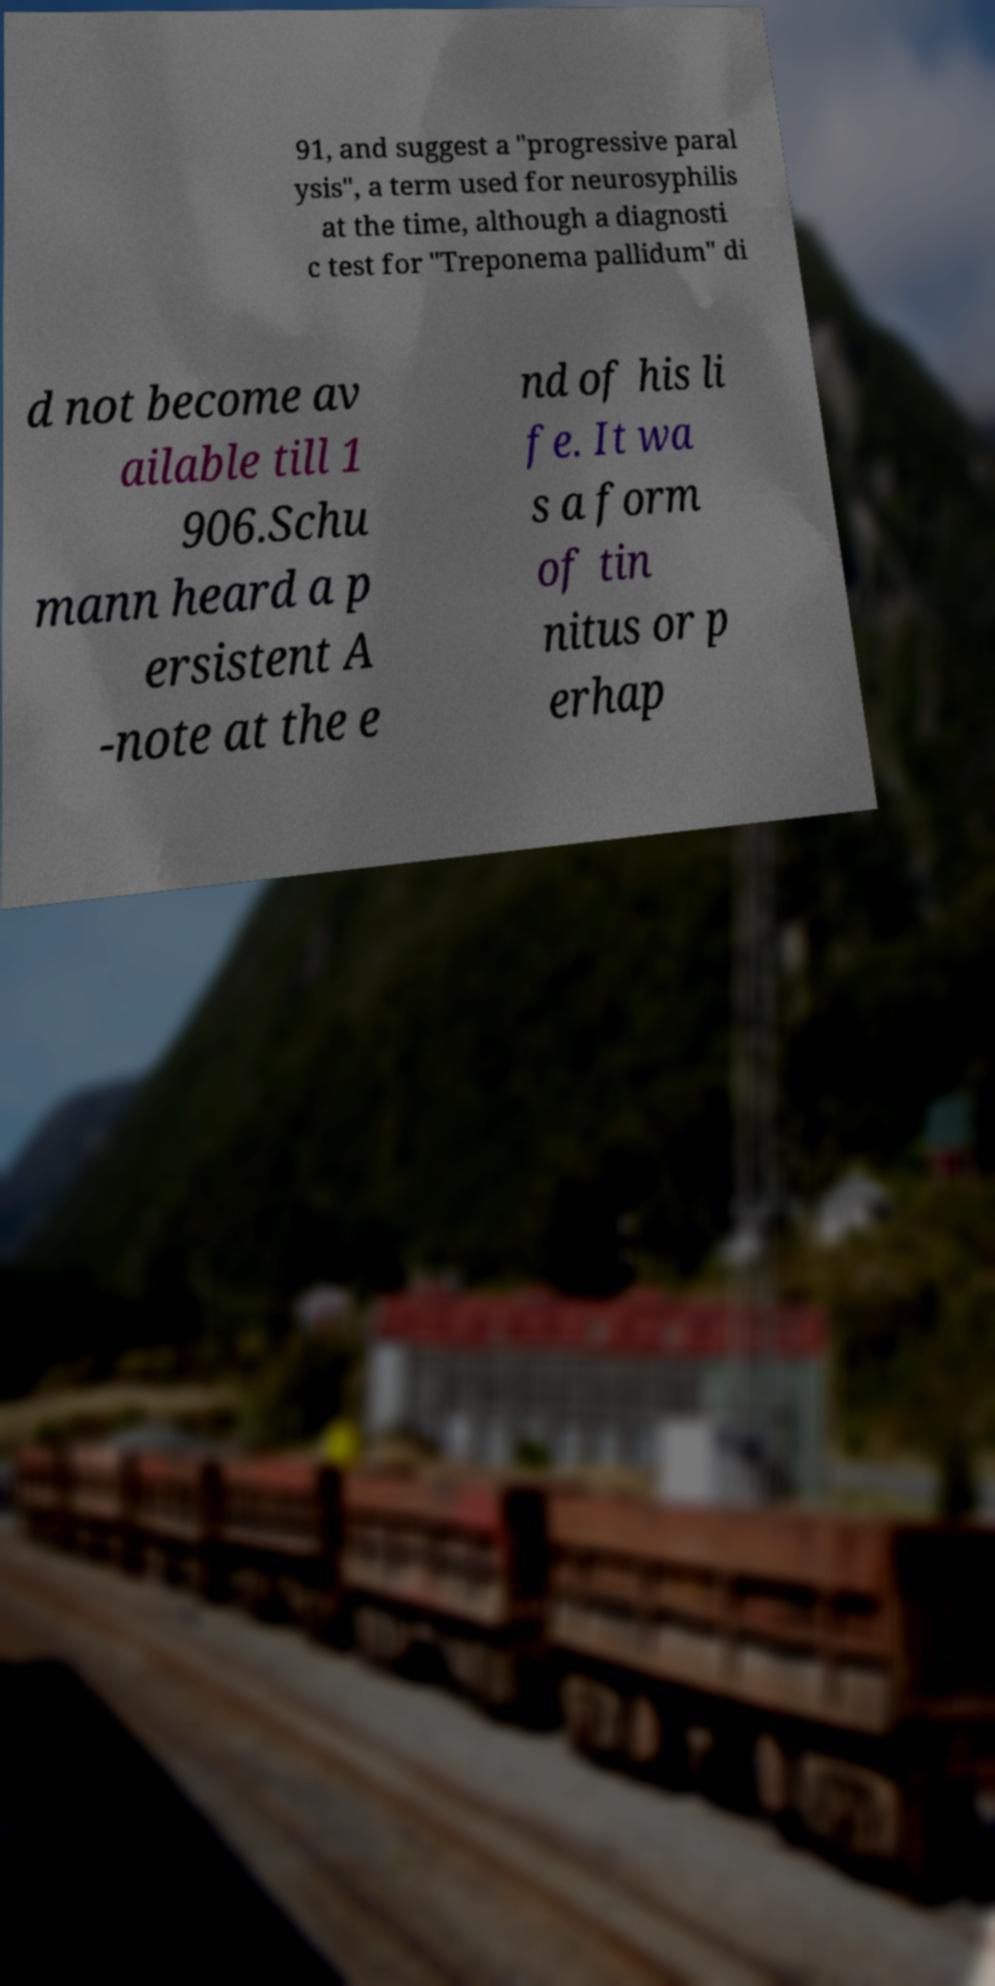Could you assist in decoding the text presented in this image and type it out clearly? 91, and suggest a "progressive paral ysis", a term used for neurosyphilis at the time, although a diagnosti c test for "Treponema pallidum" di d not become av ailable till 1 906.Schu mann heard a p ersistent A -note at the e nd of his li fe. It wa s a form of tin nitus or p erhap 